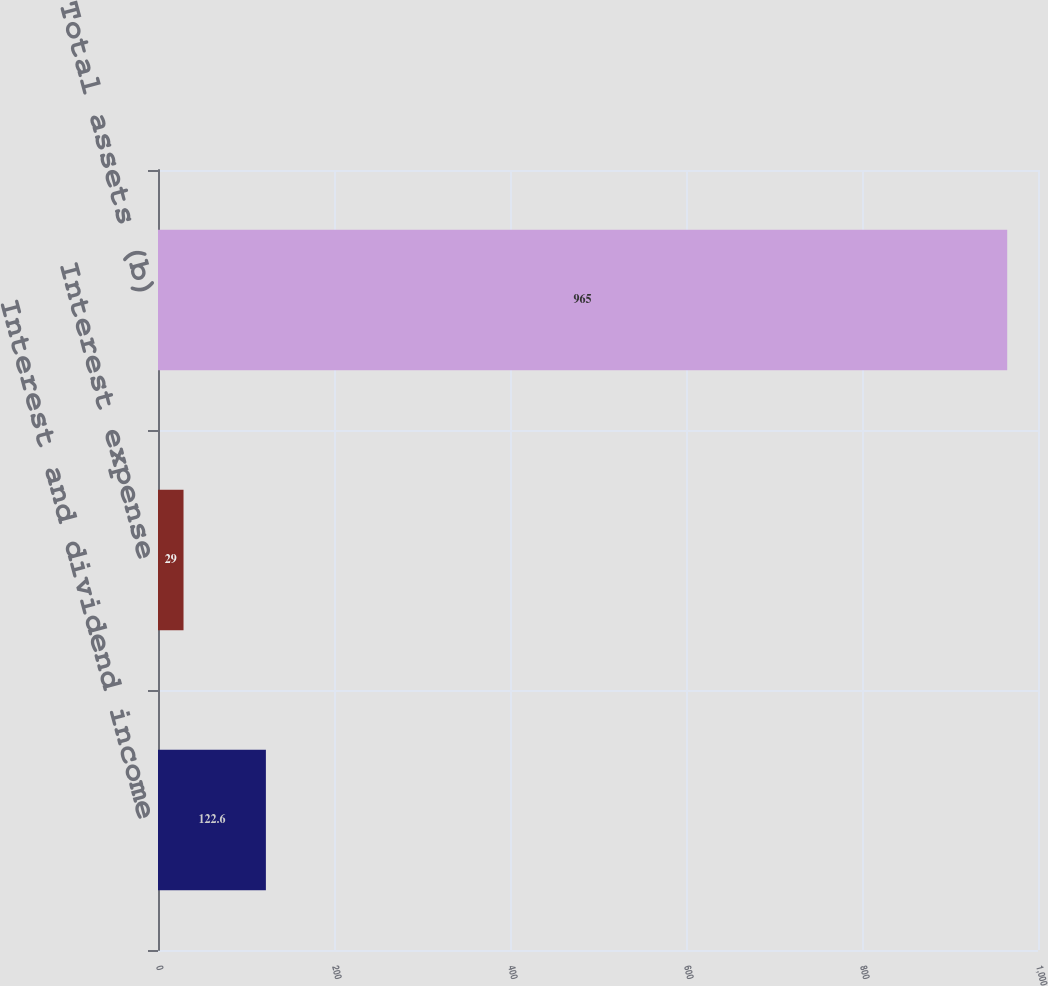Convert chart to OTSL. <chart><loc_0><loc_0><loc_500><loc_500><bar_chart><fcel>Interest and dividend income<fcel>Interest expense<fcel>Total assets (b)<nl><fcel>122.6<fcel>29<fcel>965<nl></chart> 